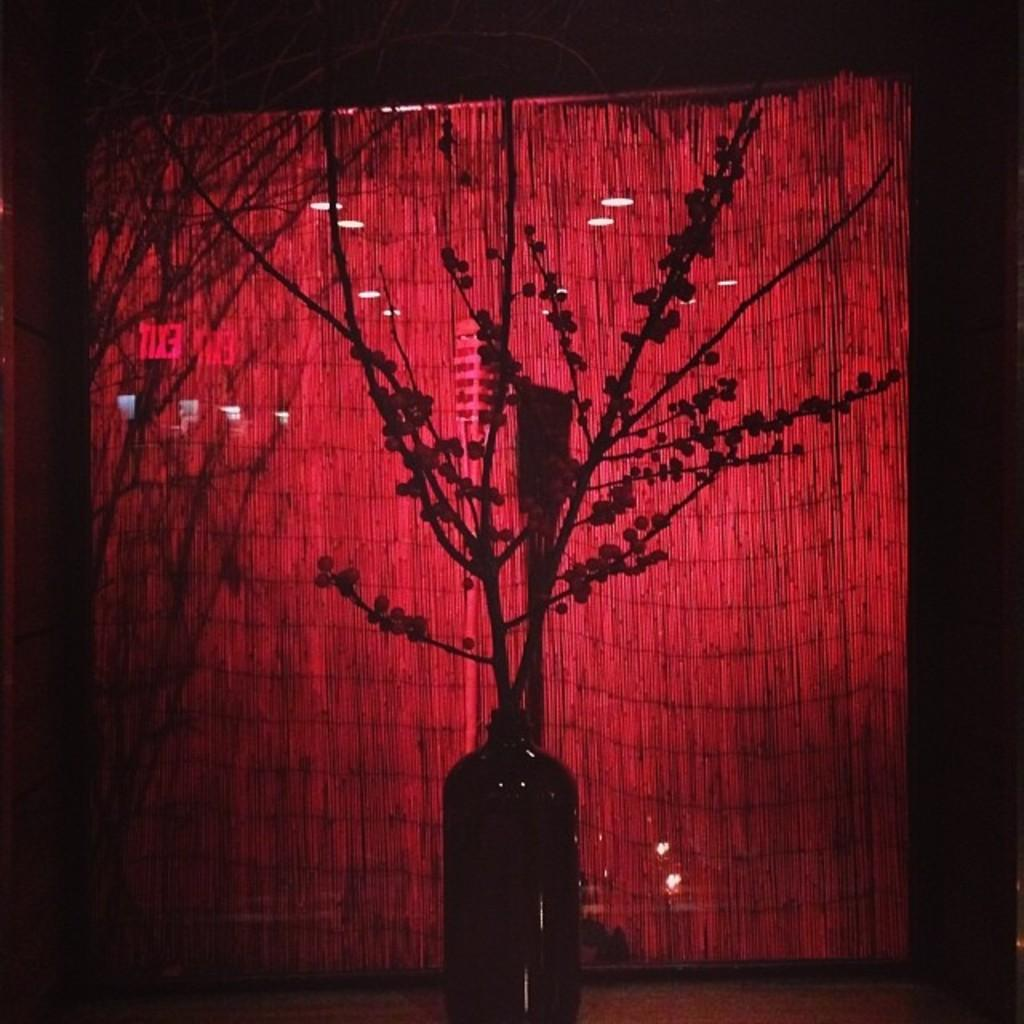What is the main object in the middle of the image? There is a flower vase in the middle of the image. Where is the flower vase placed? The flower vase is on a surface. What can be seen in the background of the image? There is a red color curtain and lights in the background. How would you describe the overall color of the background? The background is dark in color. What type of nut can be seen falling from the sky in the image? There is no nut falling from the sky in the image. The image does not depict any weather conditions or falling objects. 